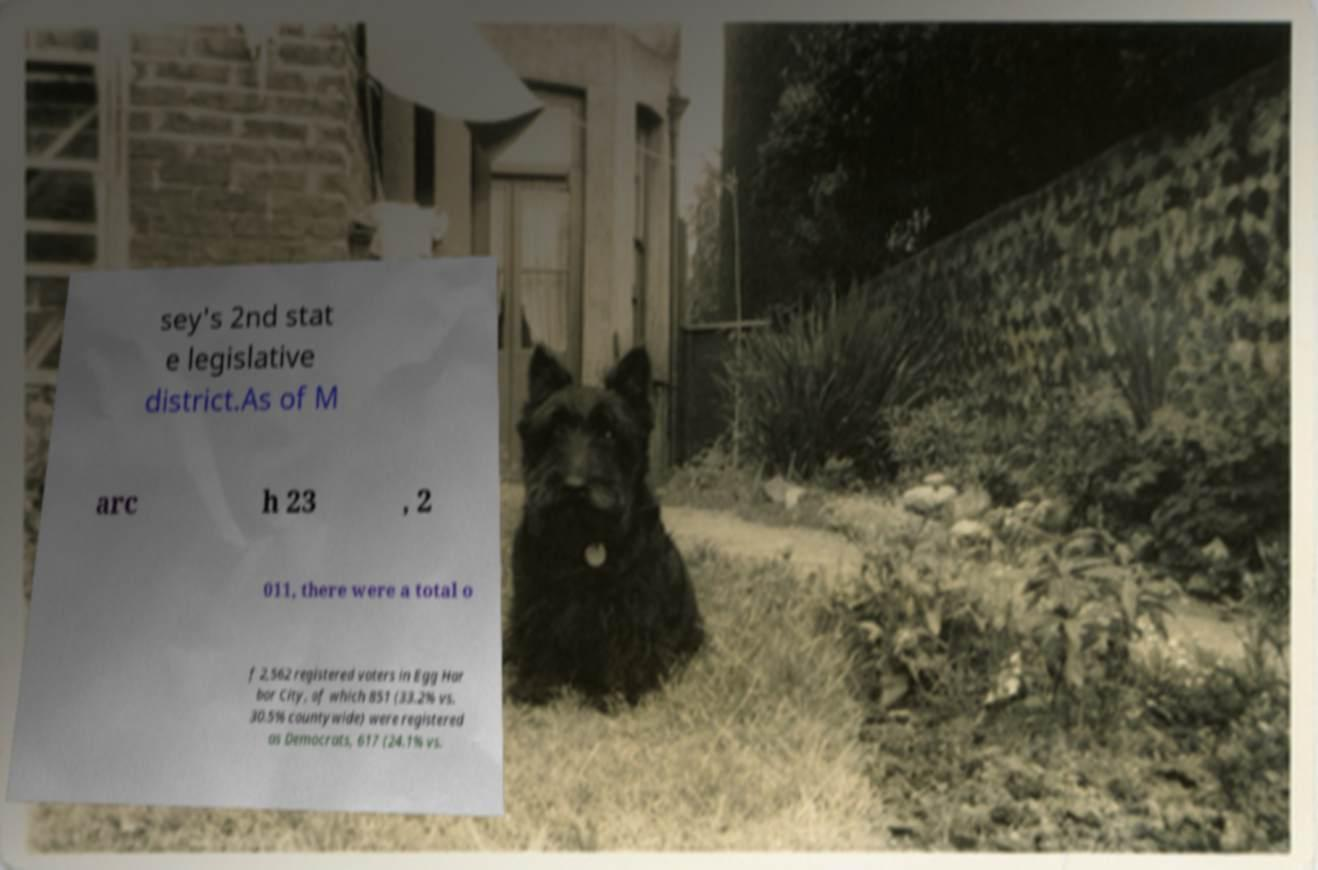What messages or text are displayed in this image? I need them in a readable, typed format. sey's 2nd stat e legislative district.As of M arc h 23 , 2 011, there were a total o f 2,562 registered voters in Egg Har bor City, of which 851 (33.2% vs. 30.5% countywide) were registered as Democrats, 617 (24.1% vs. 